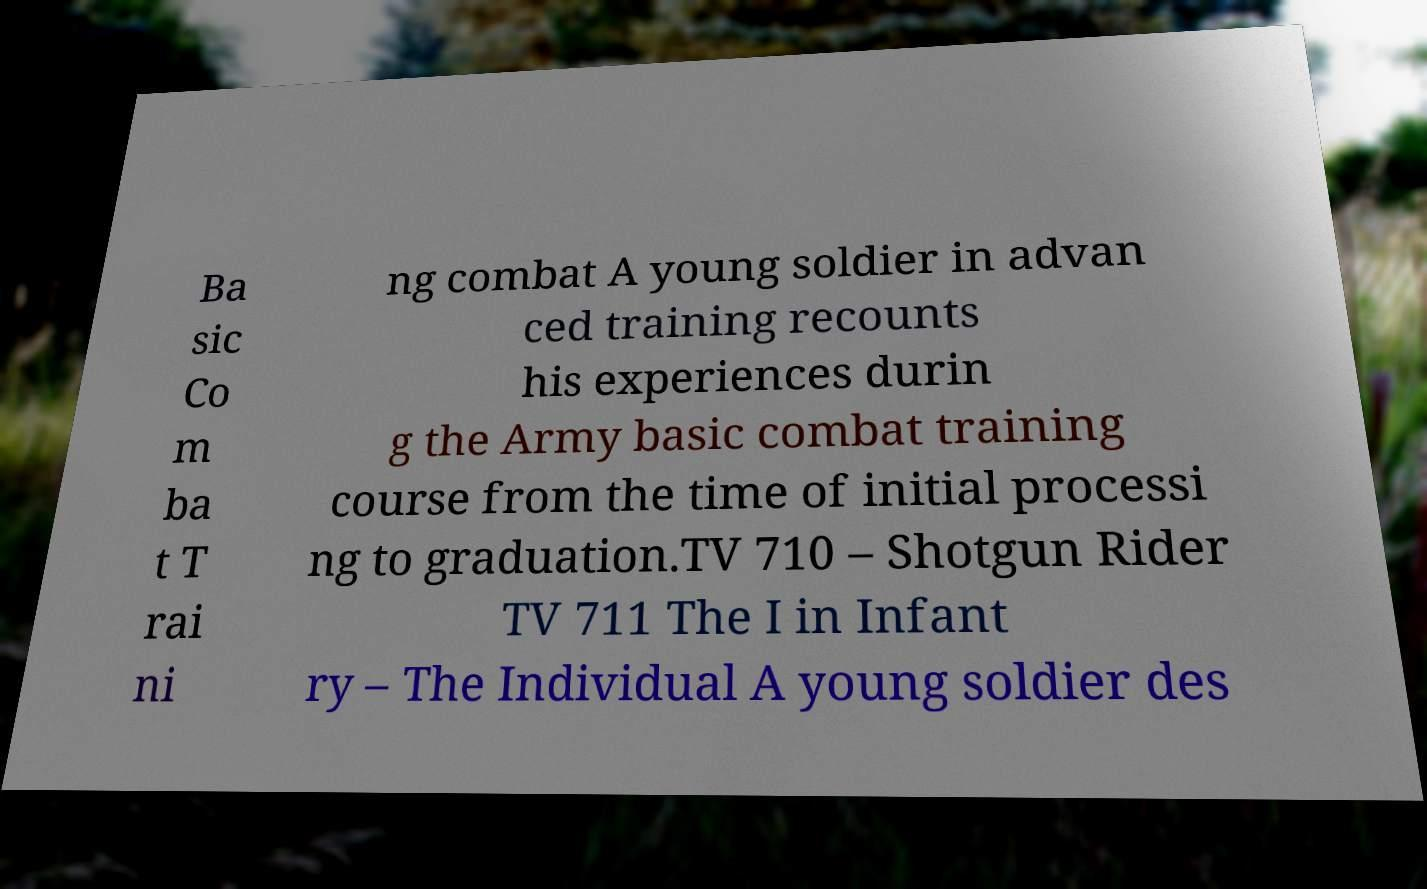I need the written content from this picture converted into text. Can you do that? Ba sic Co m ba t T rai ni ng combat A young soldier in advan ced training recounts his experiences durin g the Army basic combat training course from the time of initial processi ng to graduation.TV 710 – Shotgun Rider TV 711 The I in Infant ry – The Individual A young soldier des 